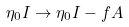Convert formula to latex. <formula><loc_0><loc_0><loc_500><loc_500>\eta _ { 0 } I \rightarrow \eta _ { 0 } I - f A</formula> 